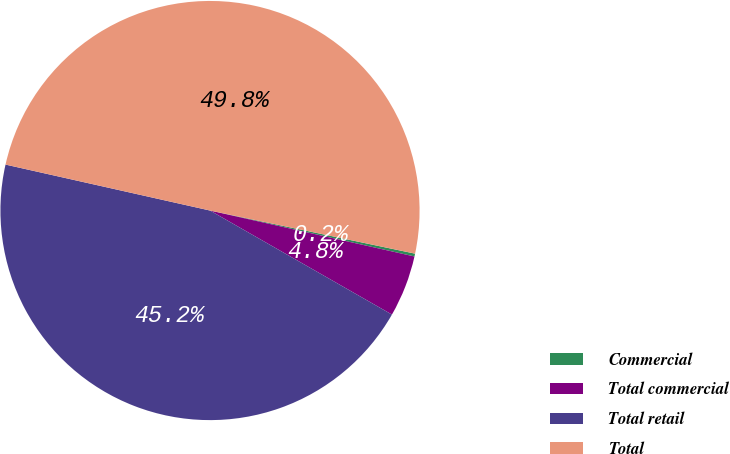<chart> <loc_0><loc_0><loc_500><loc_500><pie_chart><fcel>Commercial<fcel>Total commercial<fcel>Total retail<fcel>Total<nl><fcel>0.22%<fcel>4.75%<fcel>45.25%<fcel>49.78%<nl></chart> 